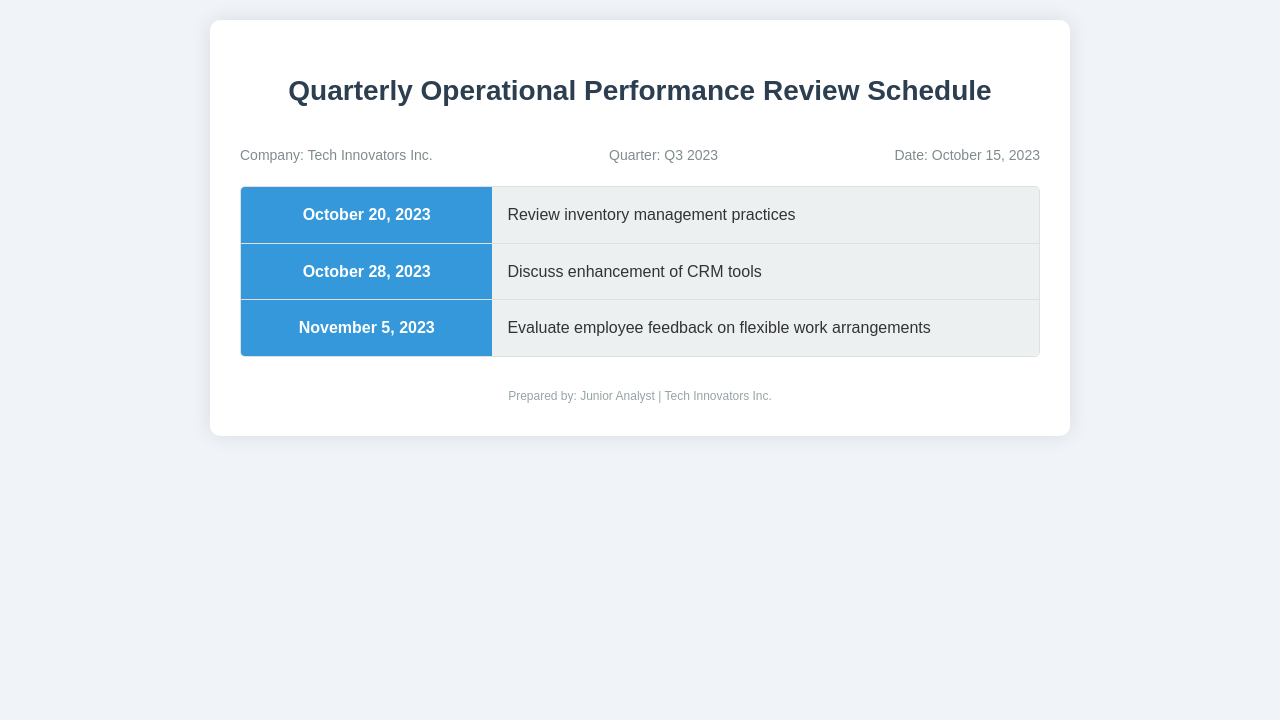What is the company name? The company's name is mentioned in the document's header under "Company."
Answer: Tech Innovators Inc What is the quarter mentioned in the document? The quarter is specified in the "Quarter" section of the document.
Answer: Q3 2023 What is the date of the operational performance review? The date is listed in the header under "Date."
Answer: October 15, 2023 What is the first agenda item on the schedule? The first item is detailed in the first entry of the schedule under "agenda."
Answer: Review inventory management practices What date is associated with the discussion on CRM tools enhancement? The date is provided in the schedule next to the corresponding agenda item.
Answer: October 28, 2023 How many schedule items are listed in total? The total is derived from counting the number of entries in the schedule section.
Answer: 3 What is the focus of the meeting on November 5, 2023? This focus is indicated under the "agenda" description for that date.
Answer: Evaluate employee feedback on flexible work arrangements Who prepared the document? The document mentions the preparer in the footer section.
Answer: Junior Analyst What background color is used for the date section? This detail can be found in the style description for the schedule items.
Answer: Blue 